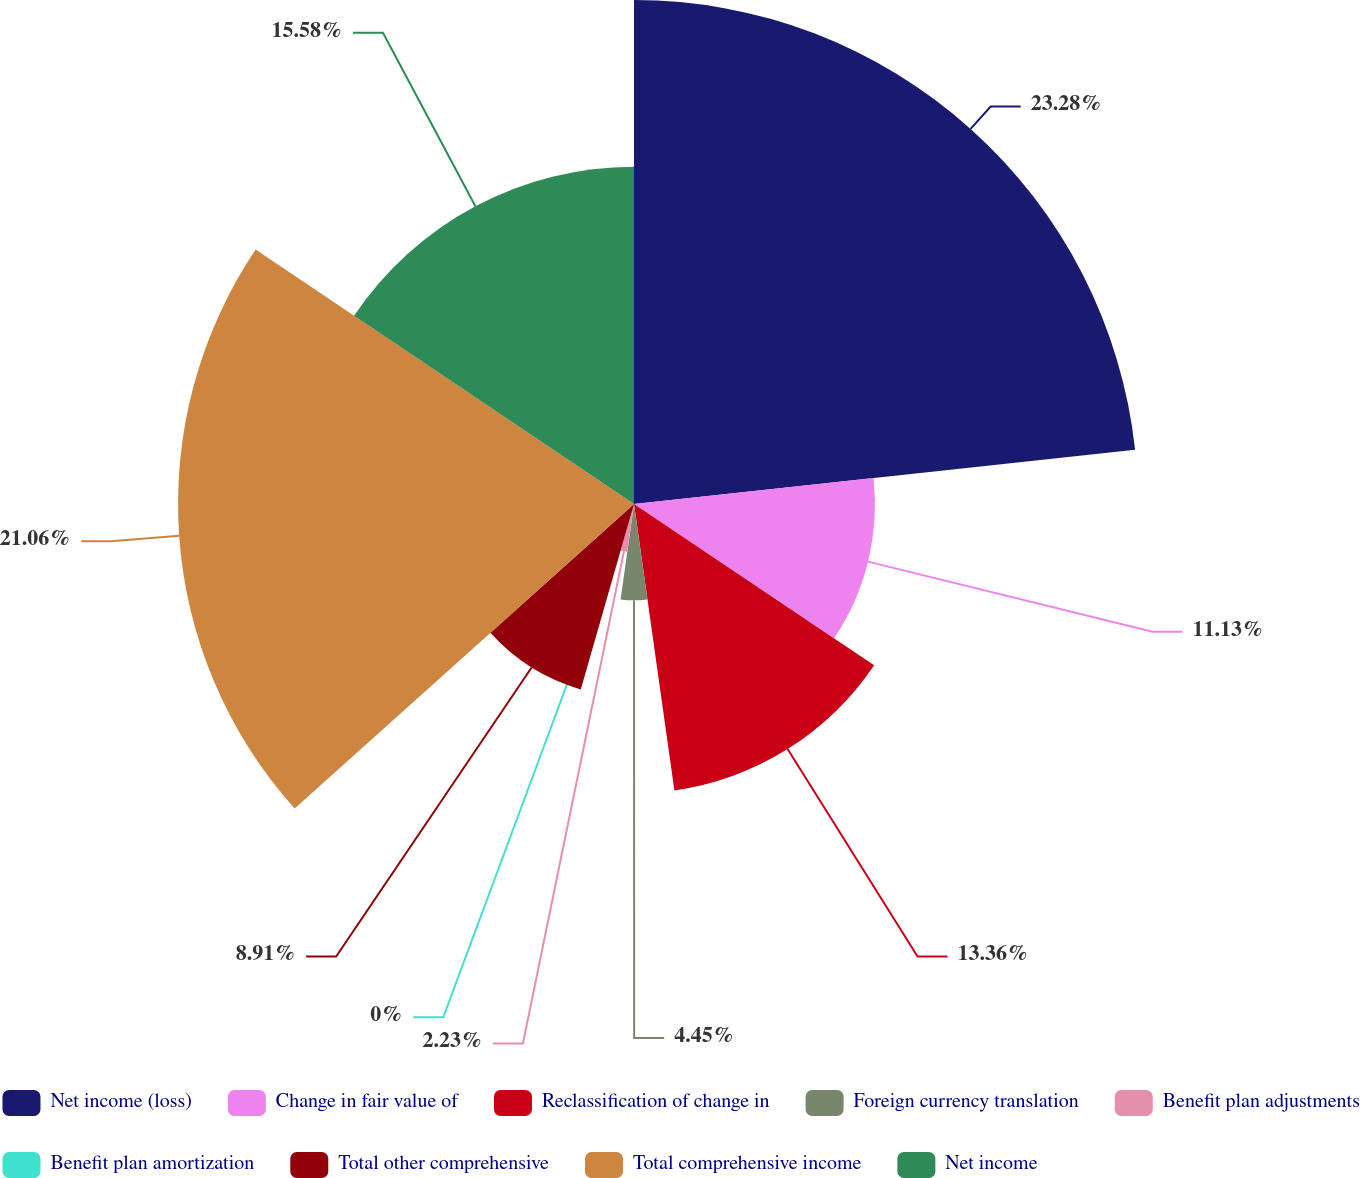Convert chart. <chart><loc_0><loc_0><loc_500><loc_500><pie_chart><fcel>Net income (loss)<fcel>Change in fair value of<fcel>Reclassification of change in<fcel>Foreign currency translation<fcel>Benefit plan adjustments<fcel>Benefit plan amortization<fcel>Total other comprehensive<fcel>Total comprehensive income<fcel>Net income<nl><fcel>23.28%<fcel>11.13%<fcel>13.36%<fcel>4.45%<fcel>2.23%<fcel>0.0%<fcel>8.91%<fcel>21.06%<fcel>15.58%<nl></chart> 